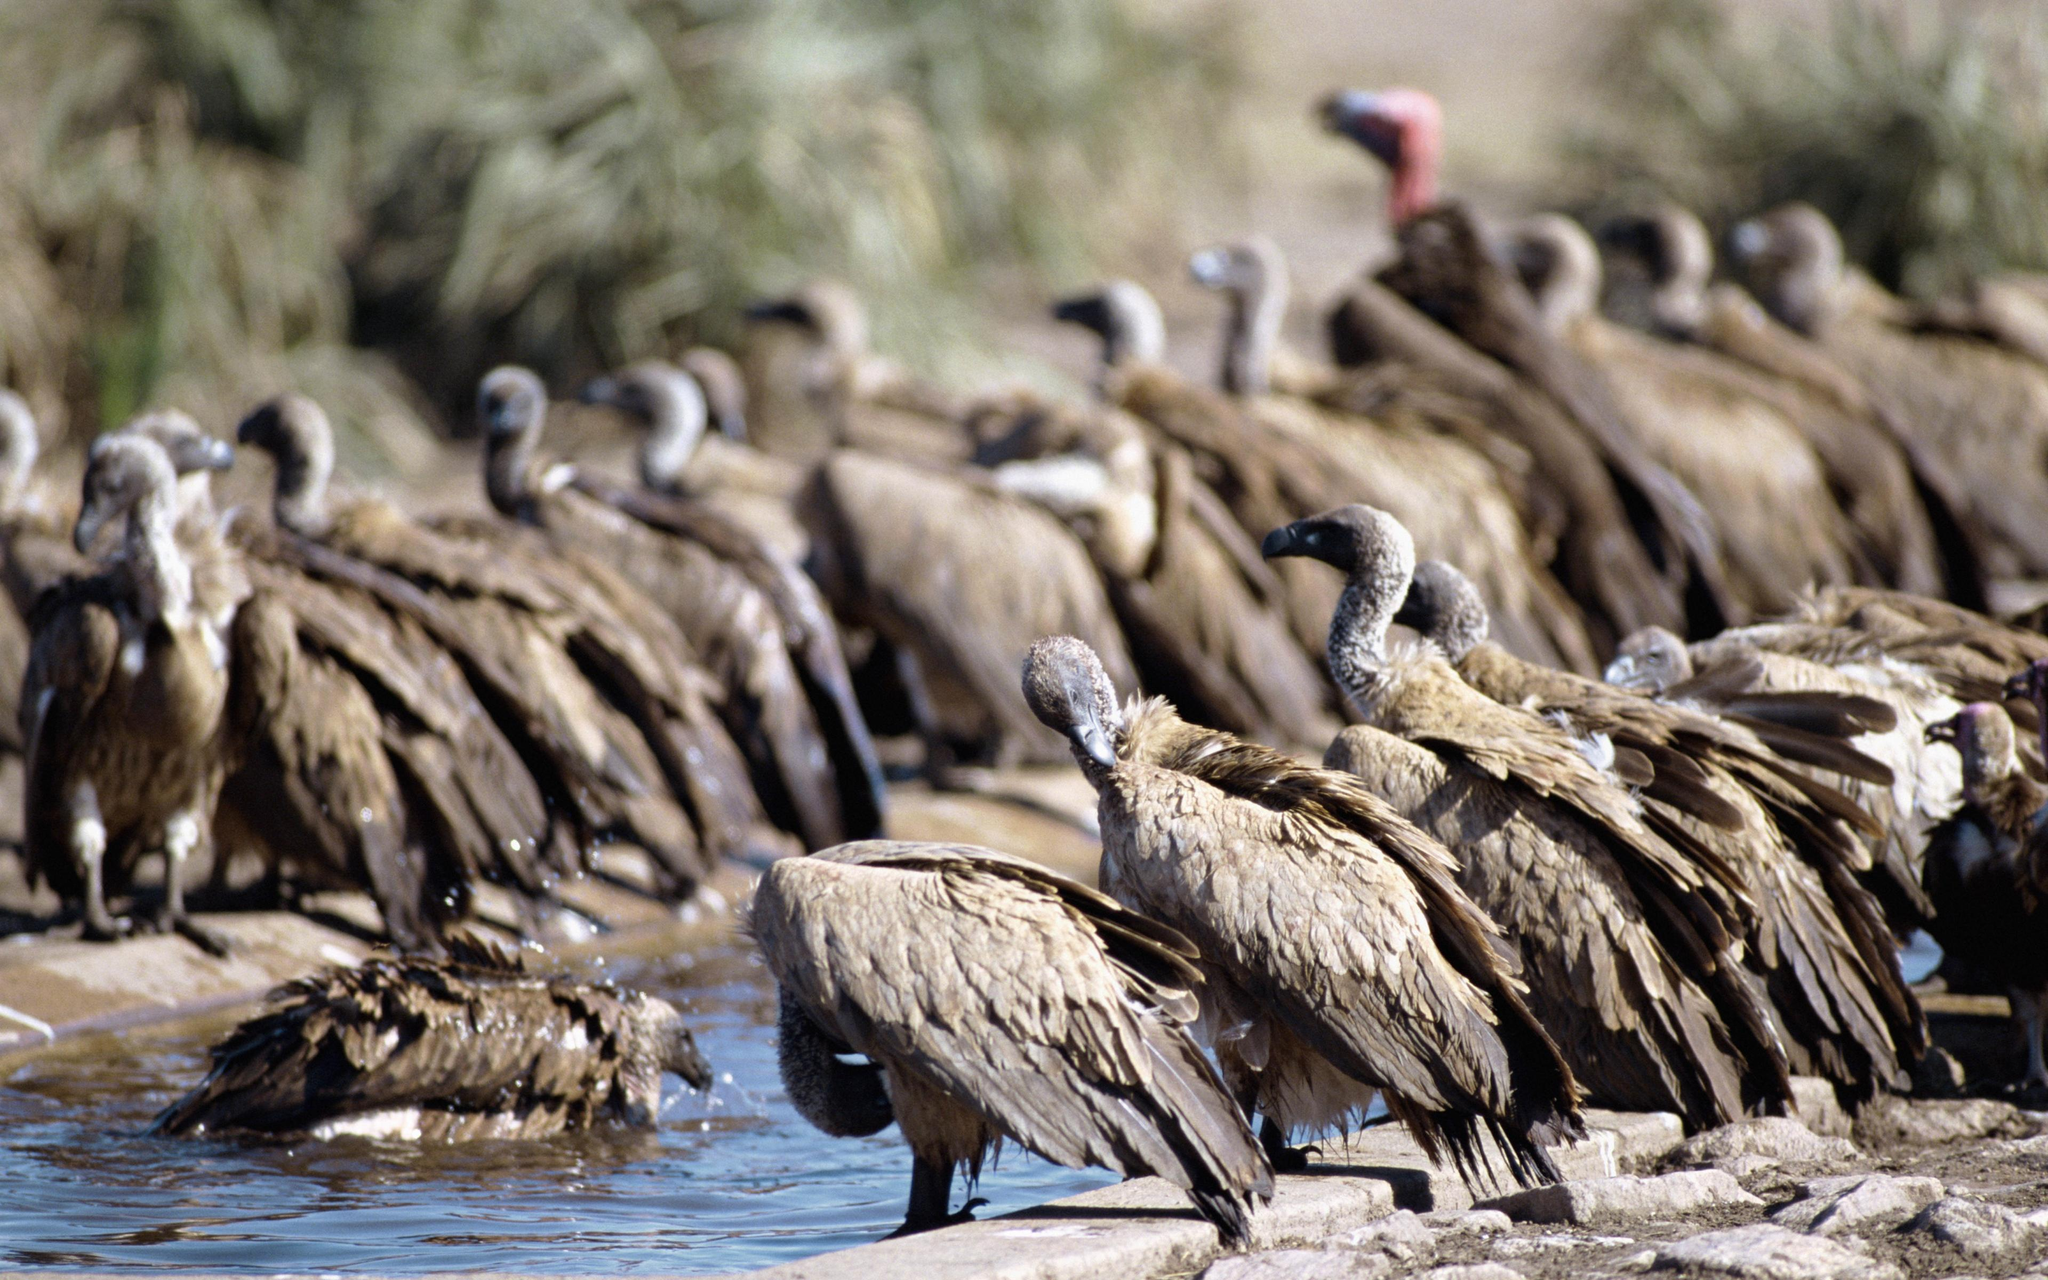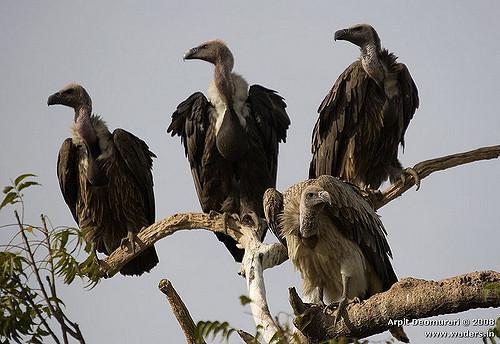The first image is the image on the left, the second image is the image on the right. Given the left and right images, does the statement "The carrion being eaten by the birds in the image on the left can be clearly seen." hold true? Answer yes or no. No. The first image is the image on the left, the second image is the image on the right. Evaluate the accuracy of this statement regarding the images: "An image shows exactly two vultures with sky-blue background.". Is it true? Answer yes or no. No. The first image is the image on the left, the second image is the image on the right. For the images displayed, is the sentence "One of the images shows exactly two birds." factually correct? Answer yes or no. No. 